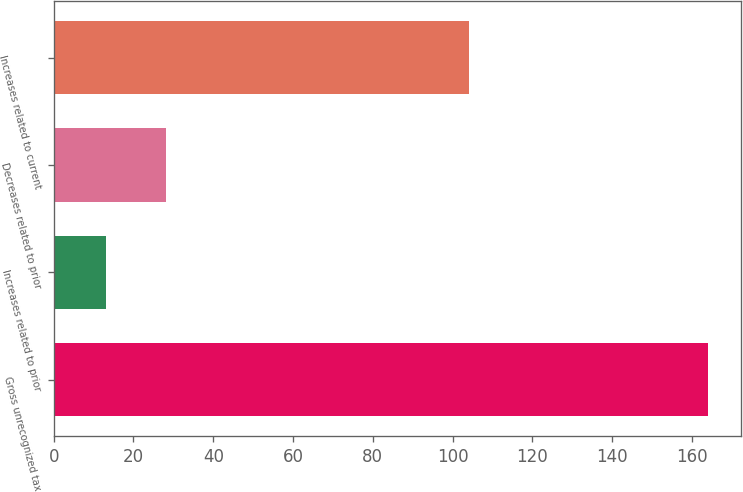<chart> <loc_0><loc_0><loc_500><loc_500><bar_chart><fcel>Gross unrecognized tax<fcel>Increases related to prior<fcel>Decreases related to prior<fcel>Increases related to current<nl><fcel>164<fcel>13<fcel>28.1<fcel>104<nl></chart> 